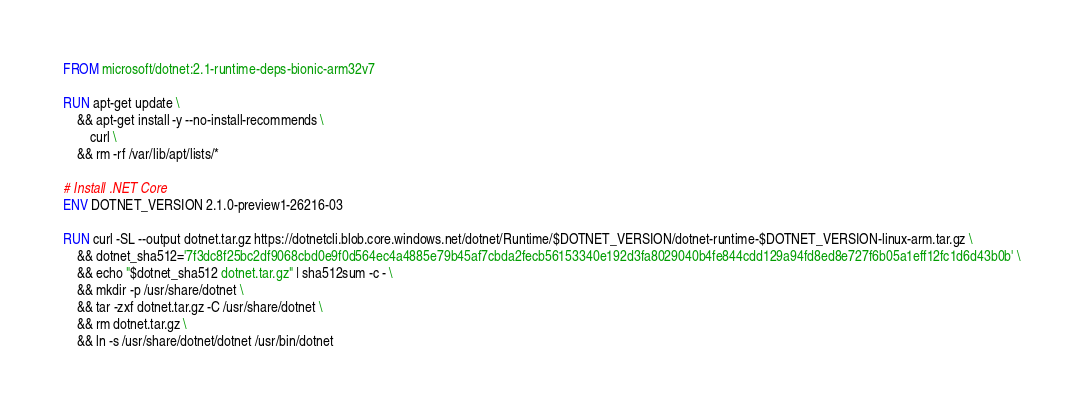<code> <loc_0><loc_0><loc_500><loc_500><_Dockerfile_>FROM microsoft/dotnet:2.1-runtime-deps-bionic-arm32v7

RUN apt-get update \
    && apt-get install -y --no-install-recommends \
        curl \
    && rm -rf /var/lib/apt/lists/*

# Install .NET Core
ENV DOTNET_VERSION 2.1.0-preview1-26216-03

RUN curl -SL --output dotnet.tar.gz https://dotnetcli.blob.core.windows.net/dotnet/Runtime/$DOTNET_VERSION/dotnet-runtime-$DOTNET_VERSION-linux-arm.tar.gz \
    && dotnet_sha512='7f3dc8f25bc2df9068cbd0e9f0d564ec4a4885e79b45af7cbda2fecb56153340e192d3fa8029040b4fe844cdd129a94fd8ed8e727f6b05a1eff12fc1d6d43b0b' \
    && echo "$dotnet_sha512 dotnet.tar.gz" | sha512sum -c - \
    && mkdir -p /usr/share/dotnet \
    && tar -zxf dotnet.tar.gz -C /usr/share/dotnet \
    && rm dotnet.tar.gz \
    && ln -s /usr/share/dotnet/dotnet /usr/bin/dotnet
</code> 